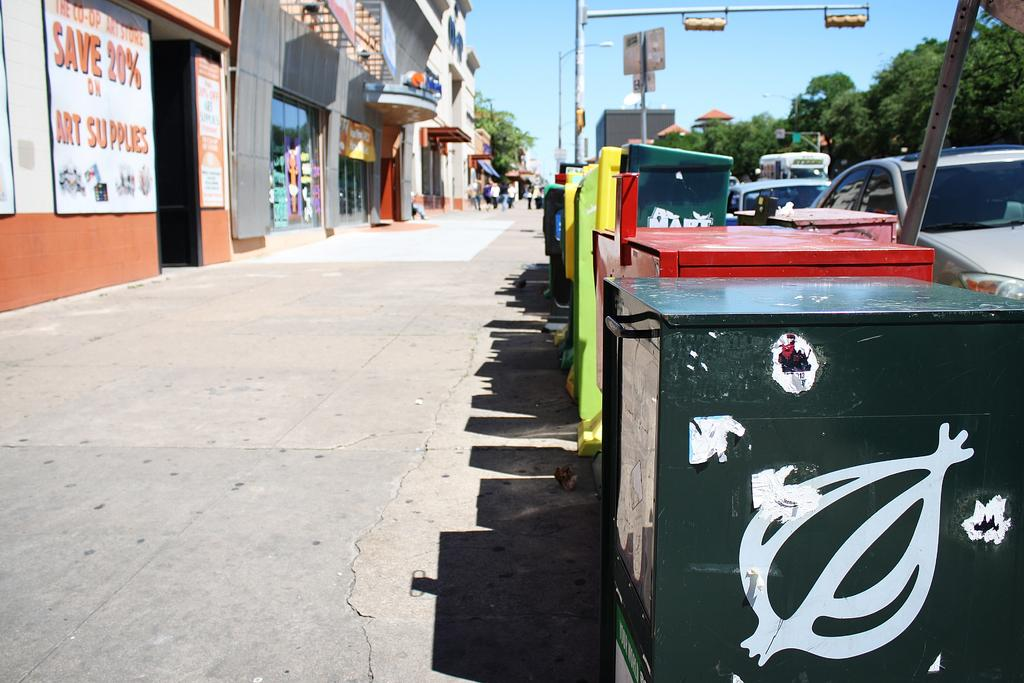<image>
Provide a brief description of the given image. A long shot of a street side with a sign for saving 20% in art supplies on a building 